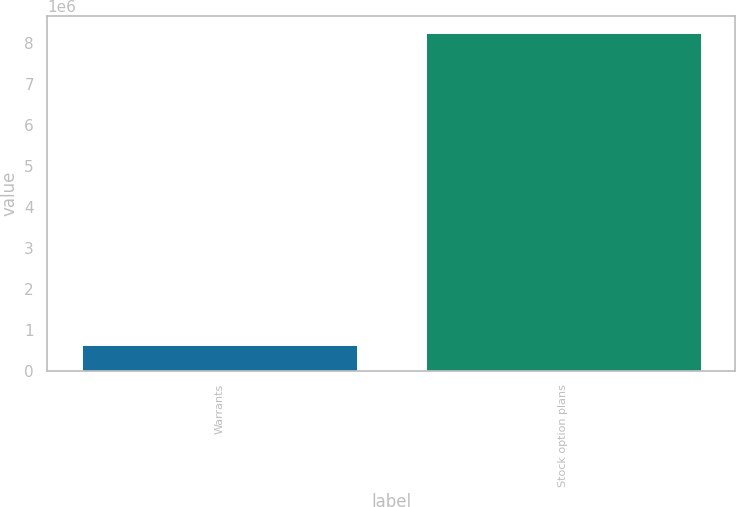Convert chart. <chart><loc_0><loc_0><loc_500><loc_500><bar_chart><fcel>Warrants<fcel>Stock option plans<nl><fcel>637151<fcel>8.23412e+06<nl></chart> 